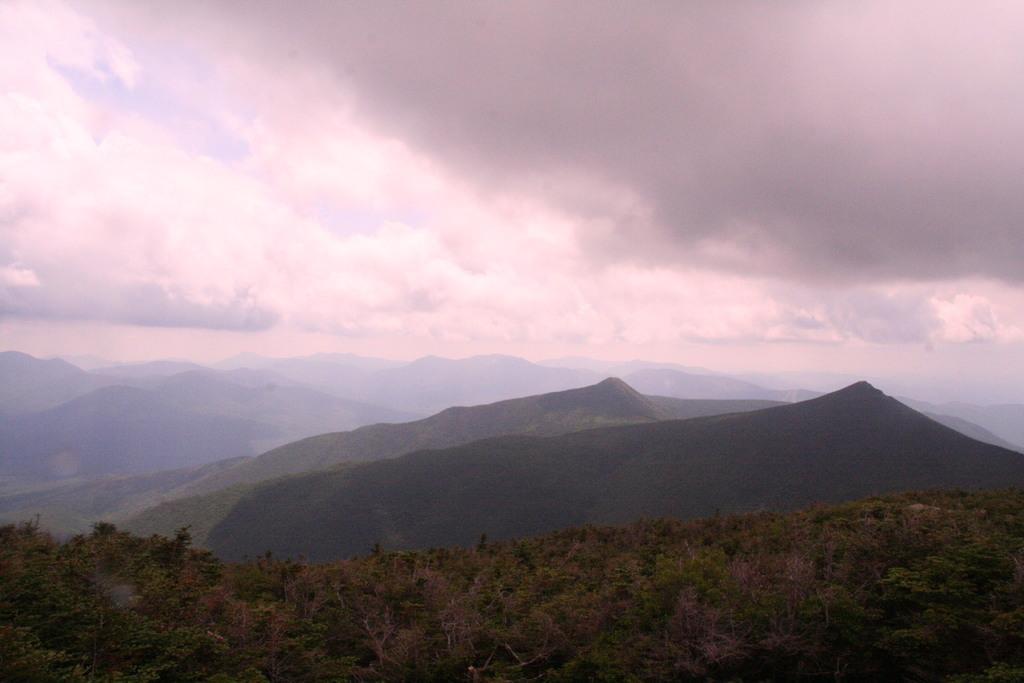Please provide a concise description of this image. In this image we can see trees, mountains and cloudy sky. 